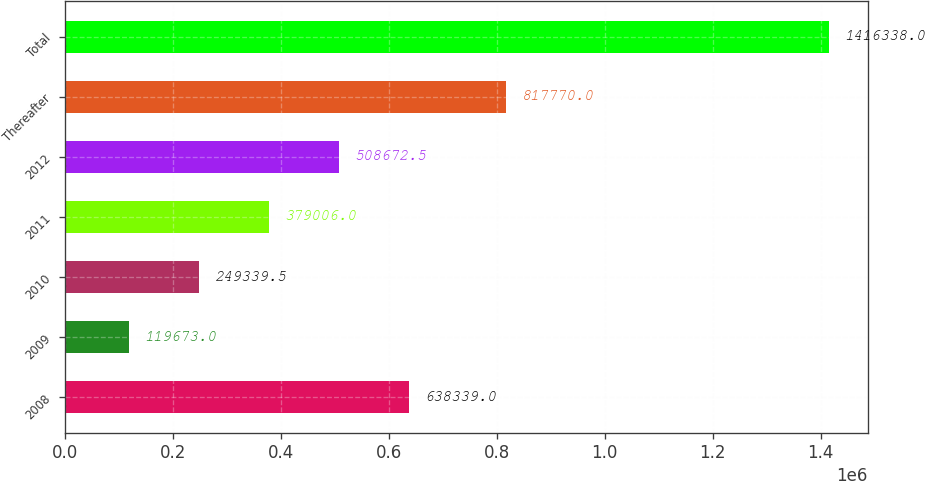Convert chart to OTSL. <chart><loc_0><loc_0><loc_500><loc_500><bar_chart><fcel>2008<fcel>2009<fcel>2010<fcel>2011<fcel>2012<fcel>Thereafter<fcel>Total<nl><fcel>638339<fcel>119673<fcel>249340<fcel>379006<fcel>508672<fcel>817770<fcel>1.41634e+06<nl></chart> 